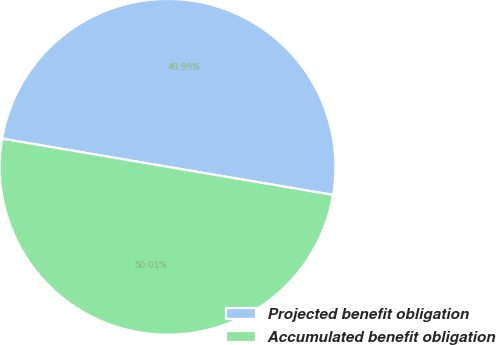<chart> <loc_0><loc_0><loc_500><loc_500><pie_chart><fcel>Projected benefit obligation<fcel>Accumulated benefit obligation<nl><fcel>49.99%<fcel>50.01%<nl></chart> 